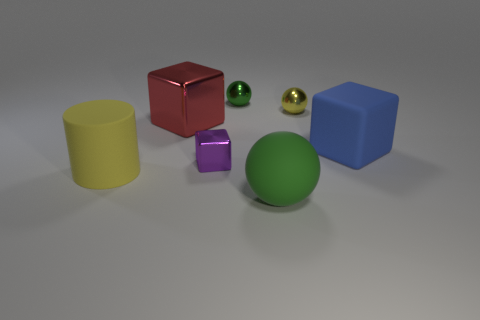Subtract all large balls. How many balls are left? 2 Subtract all purple blocks. How many blocks are left? 2 Add 1 tiny green balls. How many objects exist? 8 Subtract all spheres. How many objects are left? 4 Subtract 1 cylinders. How many cylinders are left? 0 Subtract all purple cylinders. Subtract all cyan spheres. How many cylinders are left? 1 Subtract all brown cylinders. How many red blocks are left? 1 Subtract all purple rubber cubes. Subtract all large yellow objects. How many objects are left? 6 Add 5 green rubber things. How many green rubber things are left? 6 Add 3 big red metal balls. How many big red metal balls exist? 3 